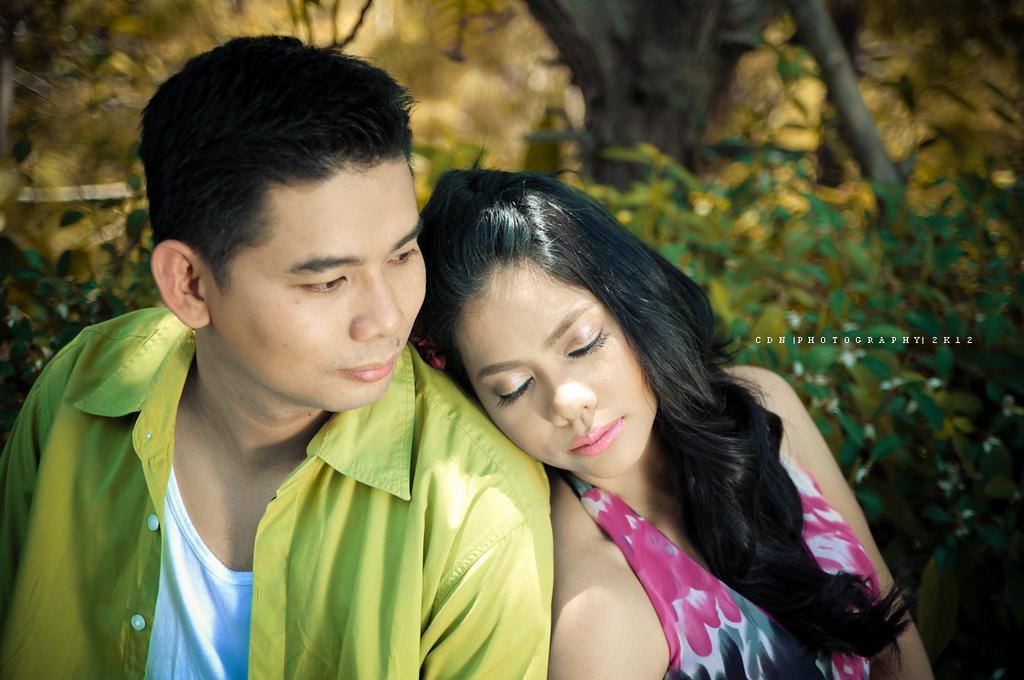Could you give a brief overview of what you see in this image? In this picture there is a man with green shirt and there is a woman with pink dress. At the back there are trees. On the right side of the image there is a text. 